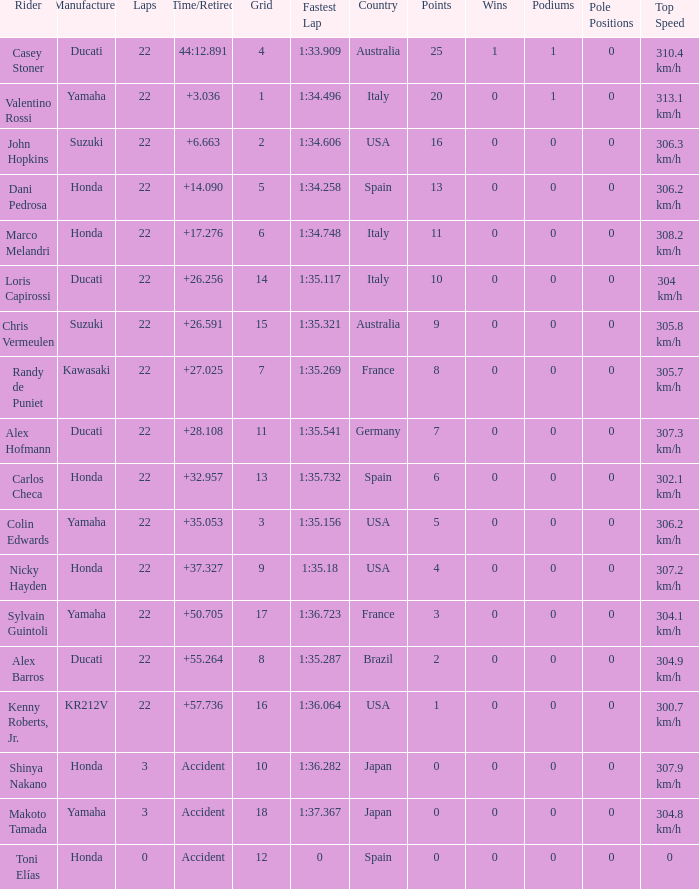What is the average grid for competitors who had more than 22 laps and time/retired of +17.276? None. 